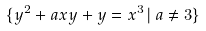Convert formula to latex. <formula><loc_0><loc_0><loc_500><loc_500>\{ y ^ { 2 } + a x y + y = x ^ { 3 } \, | \, a \neq 3 \}</formula> 